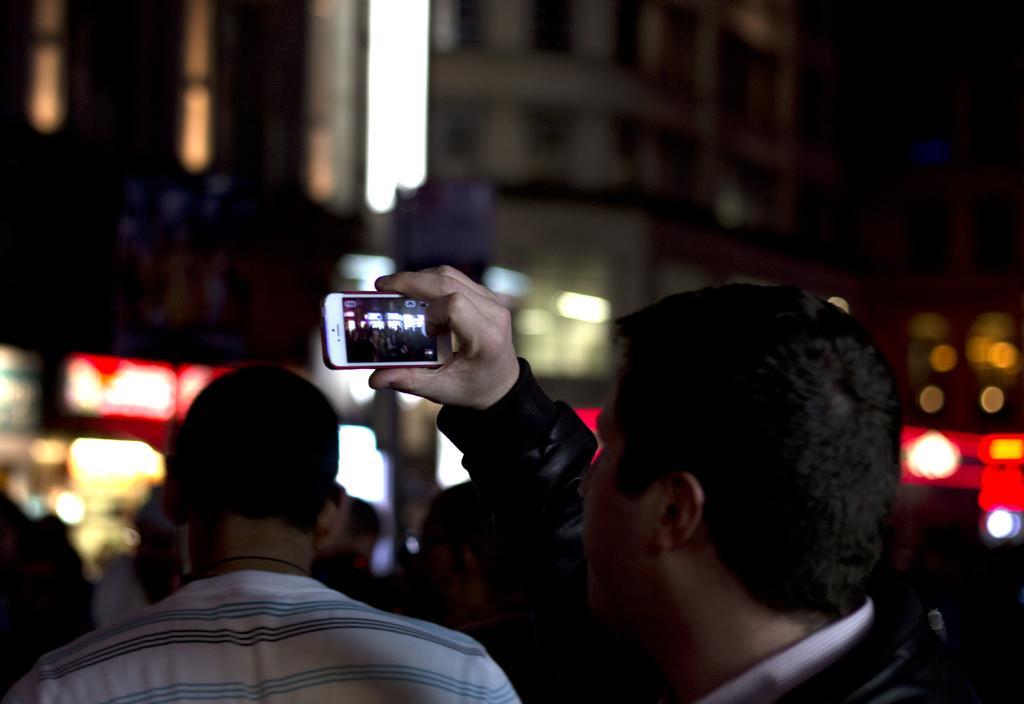Describe this image in one or two sentences. In this image, in the right side there is a man standing and he is holding a mobile phone which is in white color, he is taking a picture in his mobile, in the background there are some people walking. 